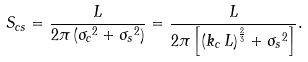Convert formula to latex. <formula><loc_0><loc_0><loc_500><loc_500>S _ { c s } = \frac { L } { 2 \pi \left ( { \sigma _ { c } } ^ { 2 } + { \sigma _ { s } } ^ { 2 } \right ) } = \frac { L } { 2 \pi \left [ \left ( k _ { c } \, L \right ) ^ { \frac { 2 } { 3 } } + { \sigma _ { s } } ^ { 2 } \right ] } .</formula> 